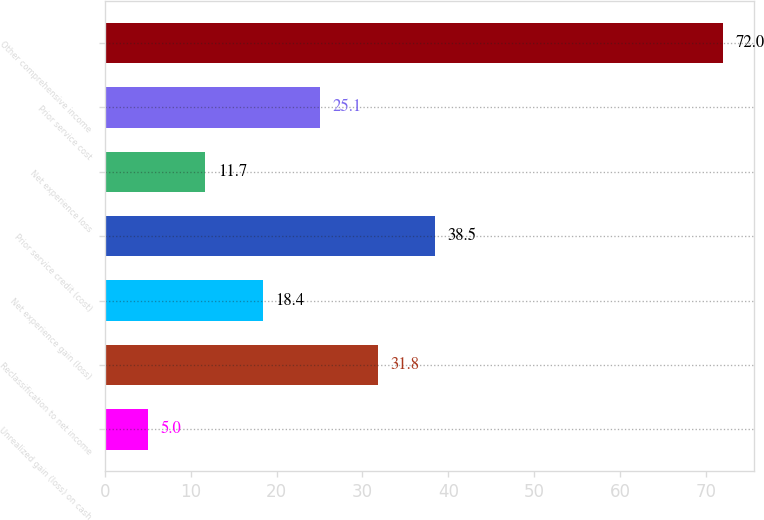Convert chart. <chart><loc_0><loc_0><loc_500><loc_500><bar_chart><fcel>Unrealized gain (loss) on cash<fcel>Reclassification to net income<fcel>Net experience gain (loss)<fcel>Prior service credit (cost)<fcel>Net experience loss<fcel>Prior service cost<fcel>Other comprehensive income<nl><fcel>5<fcel>31.8<fcel>18.4<fcel>38.5<fcel>11.7<fcel>25.1<fcel>72<nl></chart> 